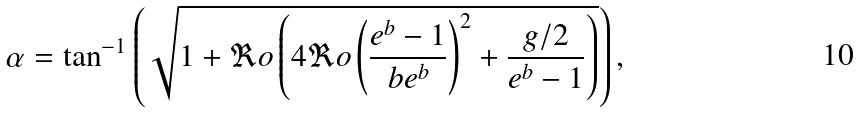Convert formula to latex. <formula><loc_0><loc_0><loc_500><loc_500>\alpha = \tan ^ { - 1 } \left ( \sqrt { 1 + \Re o \left ( 4 \Re o \left ( \frac { e ^ { b } - 1 } { b e ^ { b } } \right ) ^ { 2 } + \frac { g / 2 } { e ^ { b } - 1 } \right ) } \right ) ,</formula> 